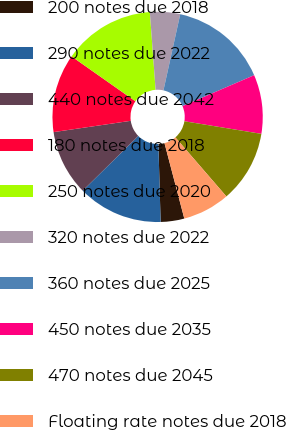Convert chart to OTSL. <chart><loc_0><loc_0><loc_500><loc_500><pie_chart><fcel>200 notes due 2018<fcel>290 notes due 2022<fcel>440 notes due 2042<fcel>180 notes due 2018<fcel>250 notes due 2020<fcel>320 notes due 2022<fcel>360 notes due 2025<fcel>450 notes due 2035<fcel>470 notes due 2045<fcel>Floating rate notes due 2018<nl><fcel>3.63%<fcel>13.07%<fcel>10.07%<fcel>12.07%<fcel>14.07%<fcel>4.63%<fcel>15.06%<fcel>9.07%<fcel>11.07%<fcel>7.26%<nl></chart> 